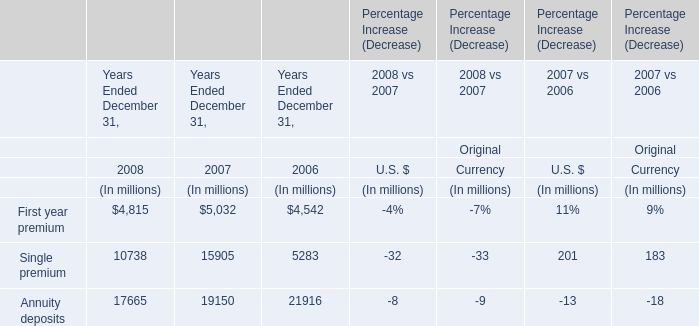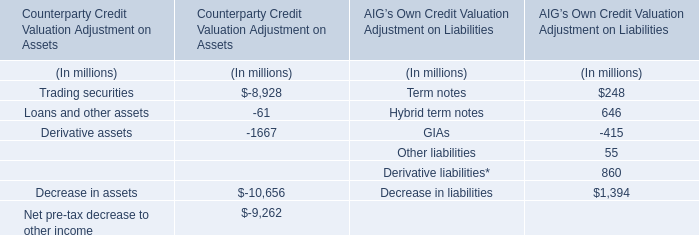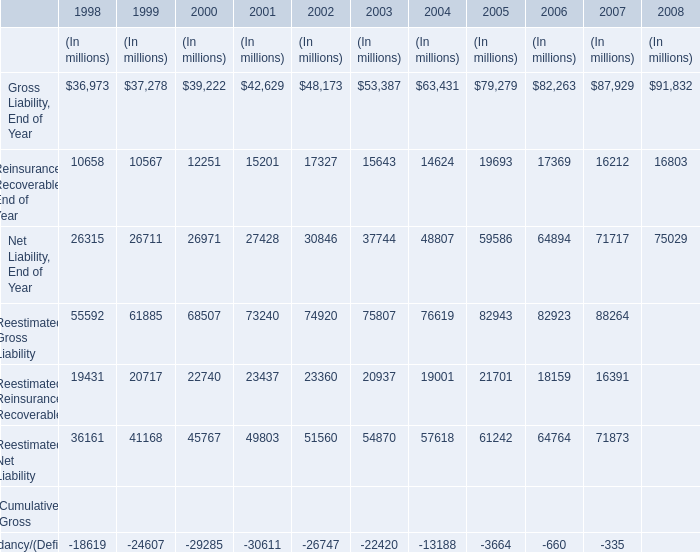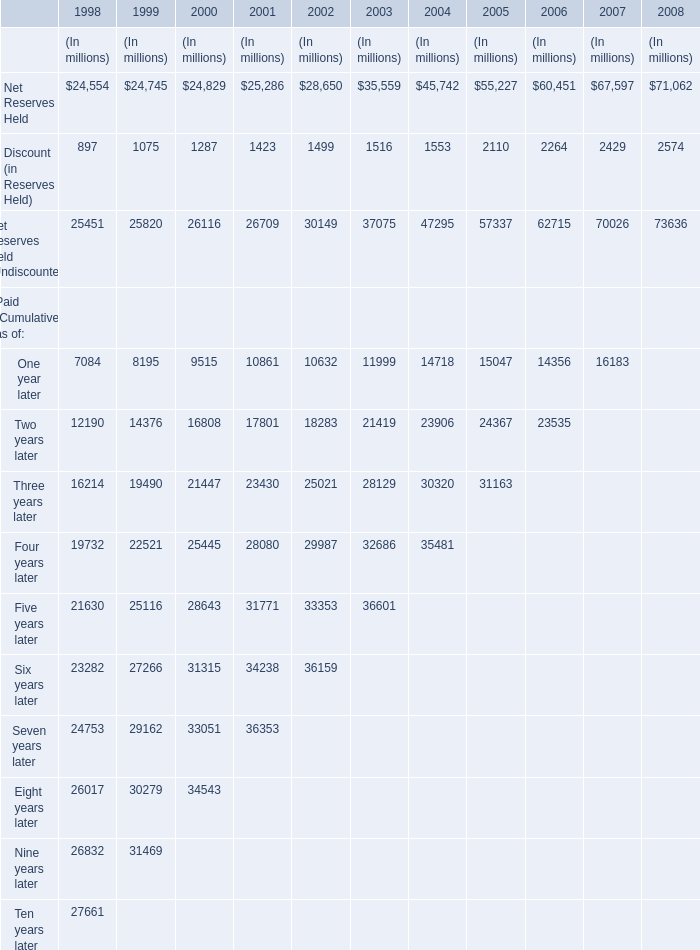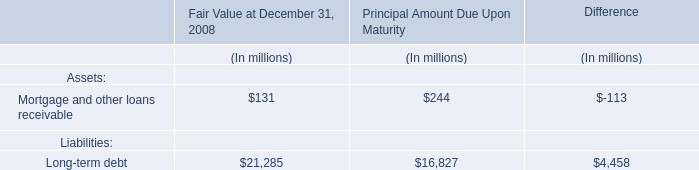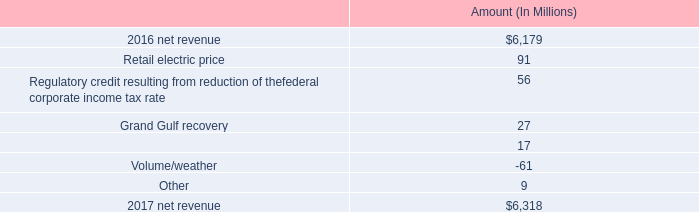what is the reduction of income tax expense as a percentage of net revenue in 2016? 
Computations: (238 / 6179)
Answer: 0.03852. 